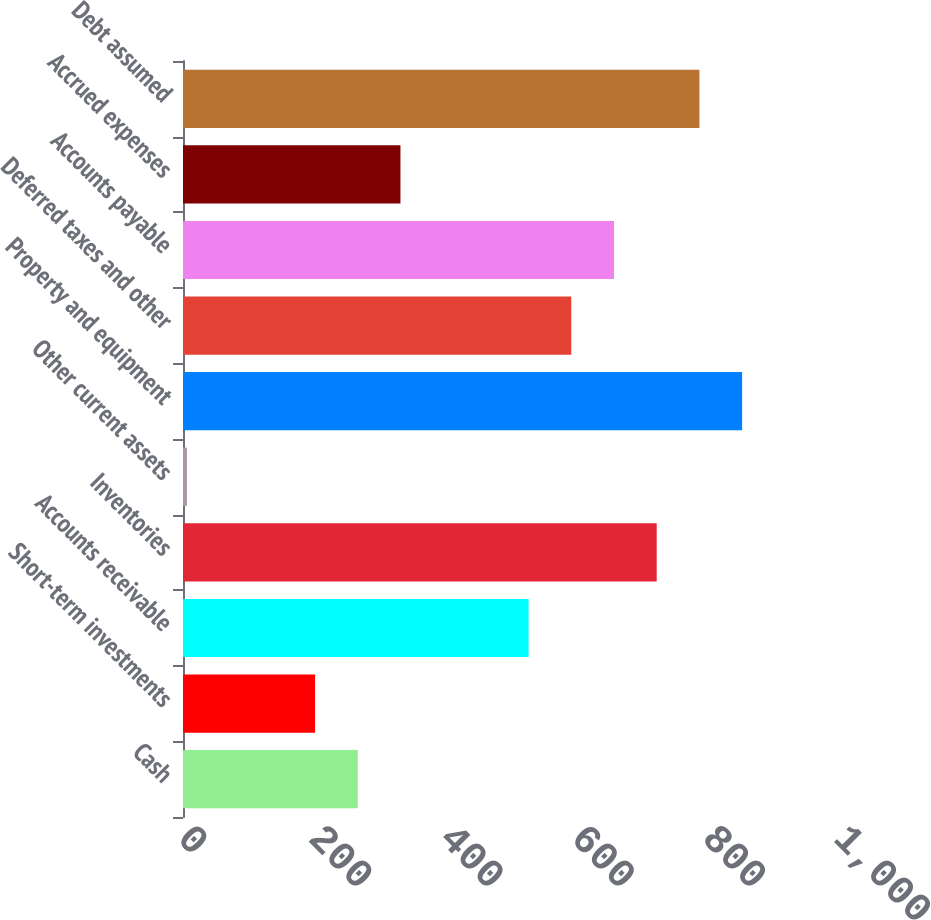<chart> <loc_0><loc_0><loc_500><loc_500><bar_chart><fcel>Cash<fcel>Short-term investments<fcel>Accounts receivable<fcel>Inventories<fcel>Other current assets<fcel>Property and equipment<fcel>Deferred taxes and other<fcel>Accounts payable<fcel>Accrued expenses<fcel>Debt assumed<nl><fcel>266.4<fcel>201.3<fcel>526.8<fcel>722.1<fcel>6<fcel>852.3<fcel>591.9<fcel>657<fcel>331.5<fcel>787.2<nl></chart> 